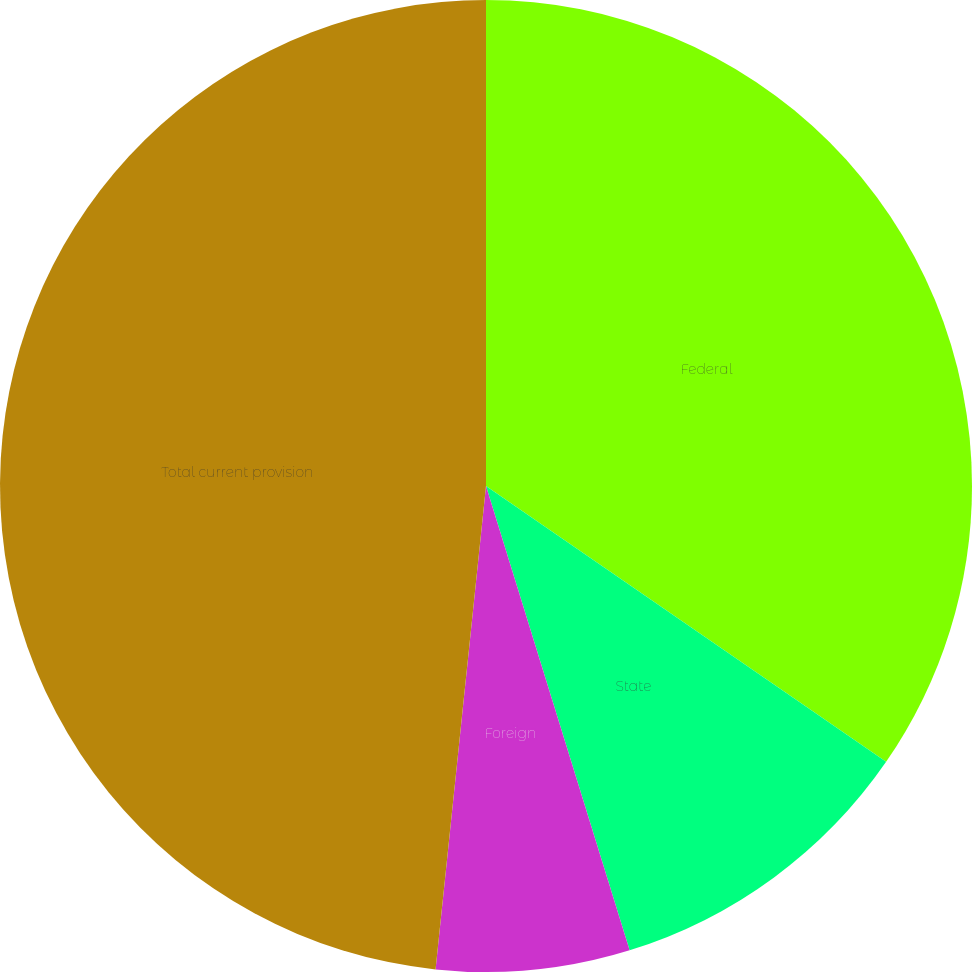<chart> <loc_0><loc_0><loc_500><loc_500><pie_chart><fcel>Federal<fcel>State<fcel>Foreign<fcel>Total current provision<nl><fcel>34.61%<fcel>10.62%<fcel>6.43%<fcel>48.35%<nl></chart> 